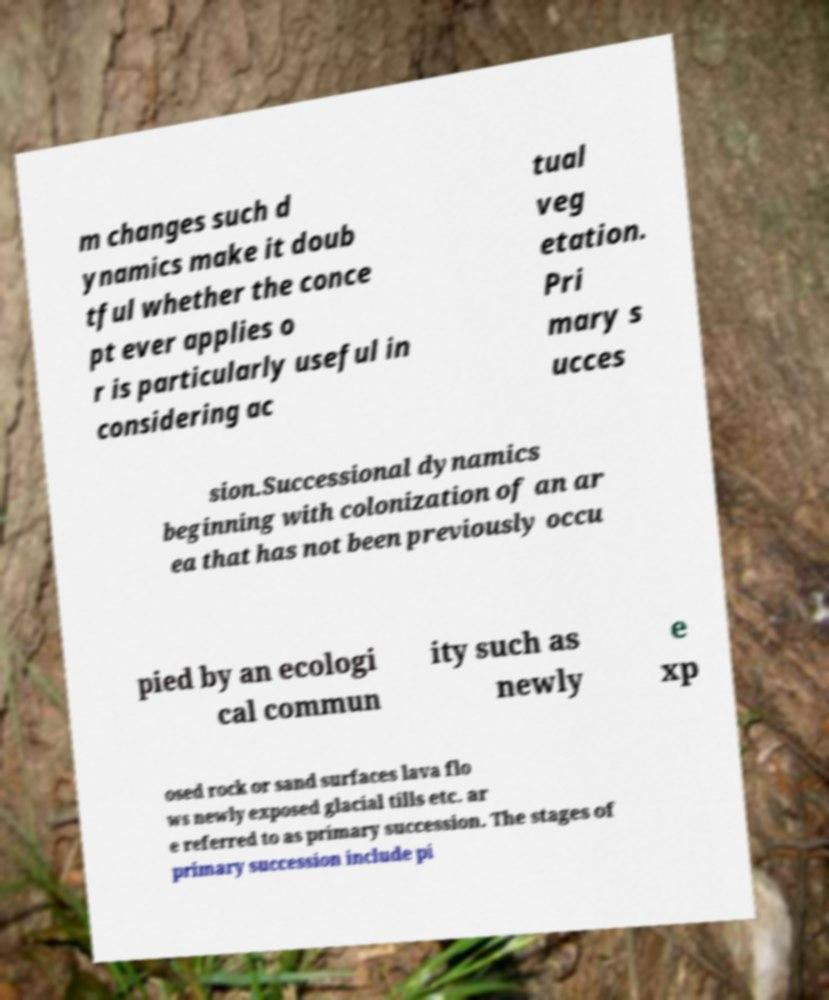Could you assist in decoding the text presented in this image and type it out clearly? m changes such d ynamics make it doub tful whether the conce pt ever applies o r is particularly useful in considering ac tual veg etation. Pri mary s ucces sion.Successional dynamics beginning with colonization of an ar ea that has not been previously occu pied by an ecologi cal commun ity such as newly e xp osed rock or sand surfaces lava flo ws newly exposed glacial tills etc. ar e referred to as primary succession. The stages of primary succession include pi 